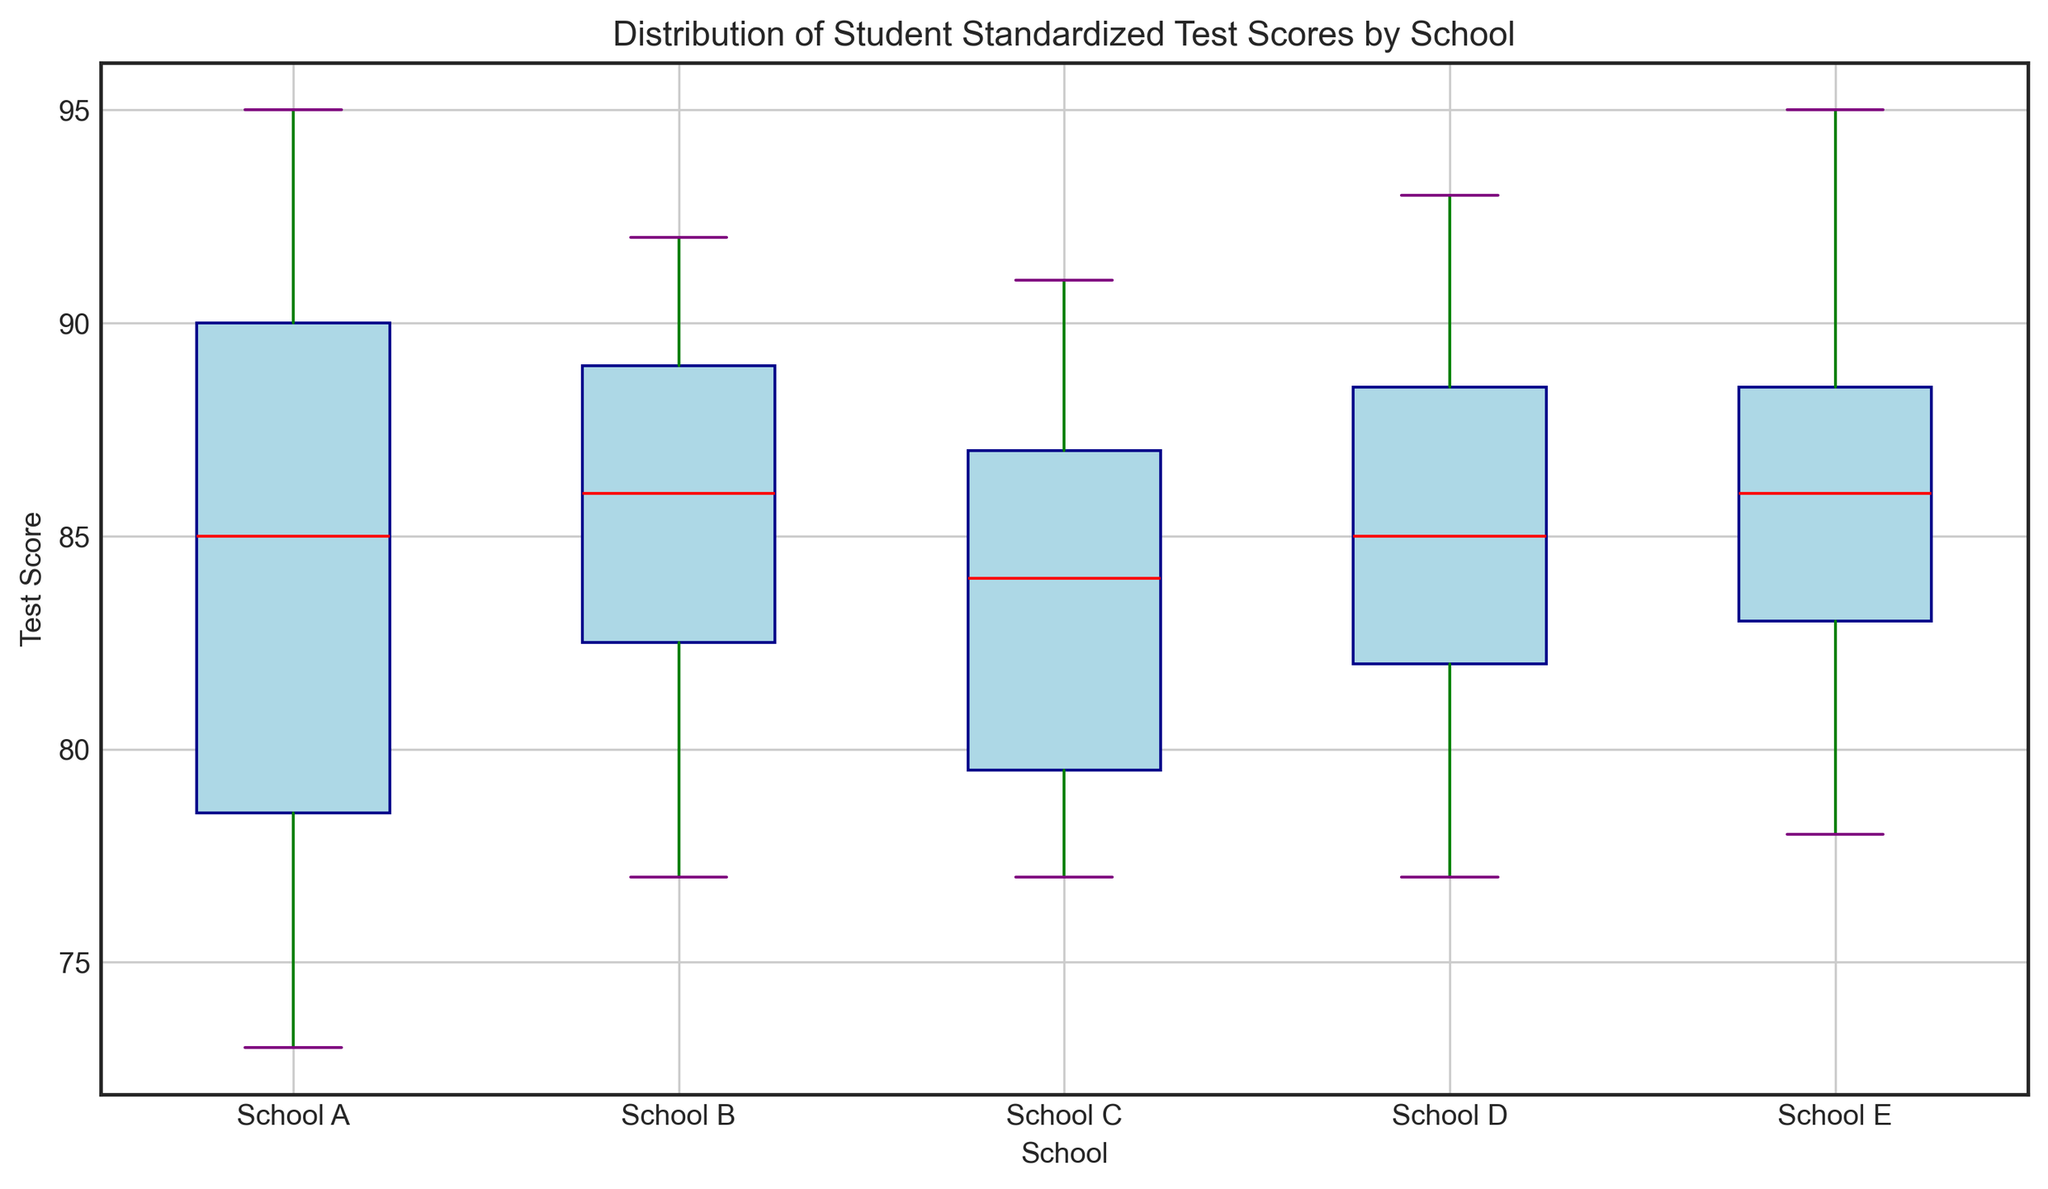What is the median test score for School A? To find the median test score for School A, locate the red line within the box plot for School A. The red line represents the median value.
Answer: 85 Which school has the highest median test score? Compare the red median lines in the box plots for each school. The highest median line corresponds to the school with the highest median test score.
Answer: School E What is the range of test scores for School B? The range is calculated by subtracting the minimum score (lower whisker) from the maximum score (upper whisker) in the box plot for School B. The lower whisker is at 77, and the upper whisker is at 92.
Answer: 15 Which school exhibits the most variability in test scores? The most variability can be seen in the school with the widest box and whiskers combined. Check each school's box plot to determine which has the widest range from the lower whisker to the upper whisker.
Answer: School E For which school does the interquartile range (IQR) show the smallest spread? The interquartile range is the distance between the bottom of the box (Q1) and the top of the box (Q3). Determine which school has the shortest height of the box.
Answer: School D Which schools have median test scores higher than 85? Locate the red median lines closest to or higher than the 85 mark. Compare across all schools.
Answer: Schools B, E What is the interquartile range (IQR) for School C? The IQR can be calculated by finding the difference between Q3 (top line of the box) and Q1 (bottom line of the box) for School C. If Q3 is at 88 and Q1 is at 78, the calculation is 88 - 78.
Answer: 10 How do the upper whiskers compare between School A and School D? The upper whiskers represent the maximum non-outlying scores. Compare the length (numerical score) of the upper whiskers for School A and School D.
Answer: School A has a shorter upper whisker than School D Are there any outliers in the test scores, and if so, for which schools? Outliers are indicated by dots or circles beyond the whiskers. Identify any such marks for each school.
Answer: None Which school has the lowest minimum test score? Check the position of the lower whisker for each school, and identify which one is the lowest.
Answer: School A 